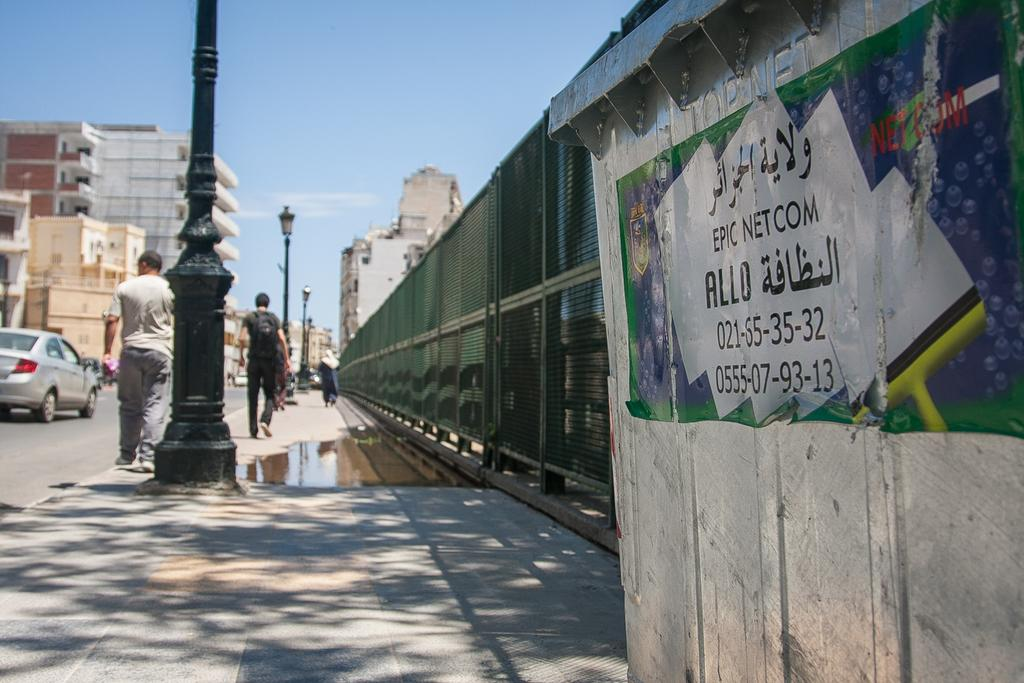<image>
Offer a succinct explanation of the picture presented. White sign on a wall which says EPIC NET COM. 